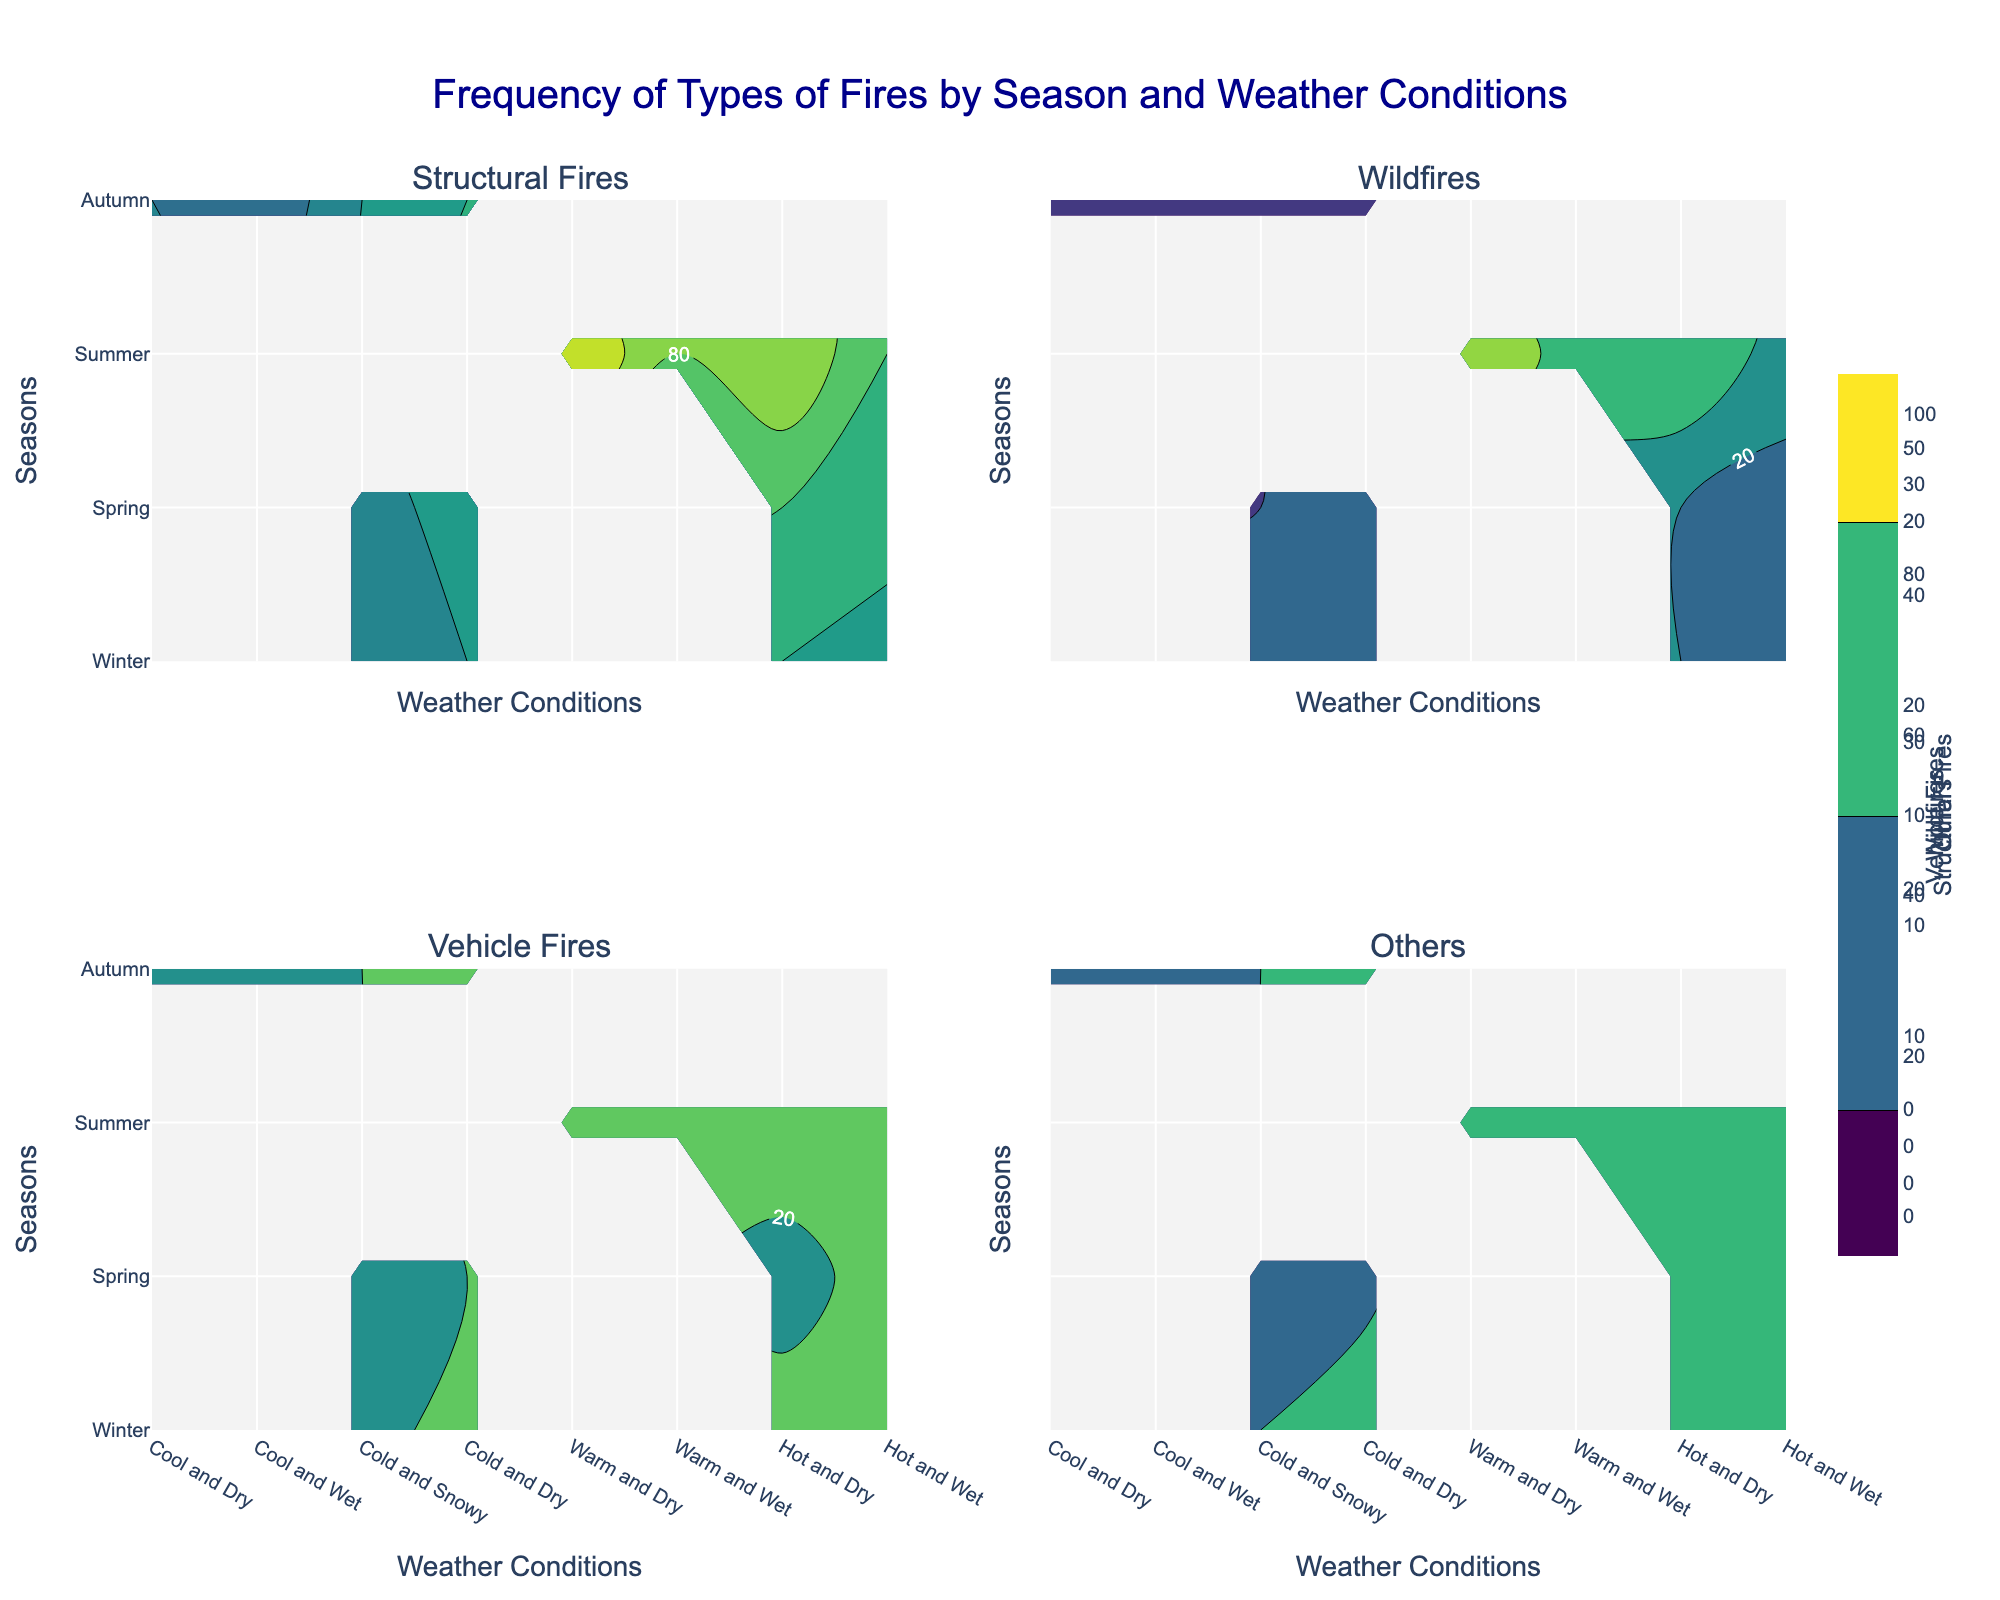What is the title of the figure? The title of the figure is typically displayed at the top center of the plot. In this case, the title clearly states, "Frequency of Types of Fires by Season and Weather Conditions."
Answer: Frequency of Types of Fires by Season and Weather Conditions Which type of fire has the highest recorded frequency in the summer under hot and dry weather conditions? To determine this, look at the contour plot section for "Structural Fires" under summer and hot and dry conditions. Inspect the labels and contours to see the highest frequency. Structural Fires peak at 100 in this case.
Answer: Structural Fires What weather condition in autumn leads to the highest number of wildfires? To find this, check the "Wildfires" contour plot for the data points corresponding to autumn, then identify which weather condition has the highest label or contour peaks. Warm and dry weather conditions show the highest number at 20.
Answer: Warm and Dry Compare the frequency of vehicle fires in winter under cool and wet conditions with that in autumn under cool and wet conditions. Which season has a higher frequency? Examine the "Vehicle Fires" contour plot and compare the labeled frequencies for cool and wet conditions in both winter and autumn. Winter shows a frequency of 25 and autumn shows 22. Winter has a higher frequency.
Answer: Winter What is the average number of vehicle fires across all weather conditions in the spring? Sum all the values of vehicle fires in the spring from the data: (18 + 20 + 15 + 25). Then calculate the average: (18 + 20 + 15 + 25) / 4 = 19.5.
Answer: 19.5 For wildfires, which season and weather condition combination shows the lowest frequency? Check the contour plot for "Wildfires" and identify the combination with the smallest labeled value or contour peak. Winter under cold and snowy conditions has the lowest value at 3.
Answer: Winter, Cold and Snowy How does the frequency of structural fires in summer under hot and wet conditions compare to that in summer under warm and dry conditions? For the given fire types, compare the values in the contour plot for both conditions. Hot and wet conditions in summer have a frequency of 80, whereas warm and dry conditions have 90, making the latter higher.
Answer: Warm and Dry What is the most common weather condition associated with structural fires in the spring? Look for the highest frequency values in the "Structural Fires" plot for spring, which can be found under warm and dry conditions with a frequency of 70.
Answer: Warm and Dry Add the frequencies of 'Other' fires in autumn under all weather conditions. Sum up the values from "Others" in the autumn section of the data: (10 + 12 + 15 + 13). This gives 10 + 12 + 15 + 13 = 50.
Answer: 50 